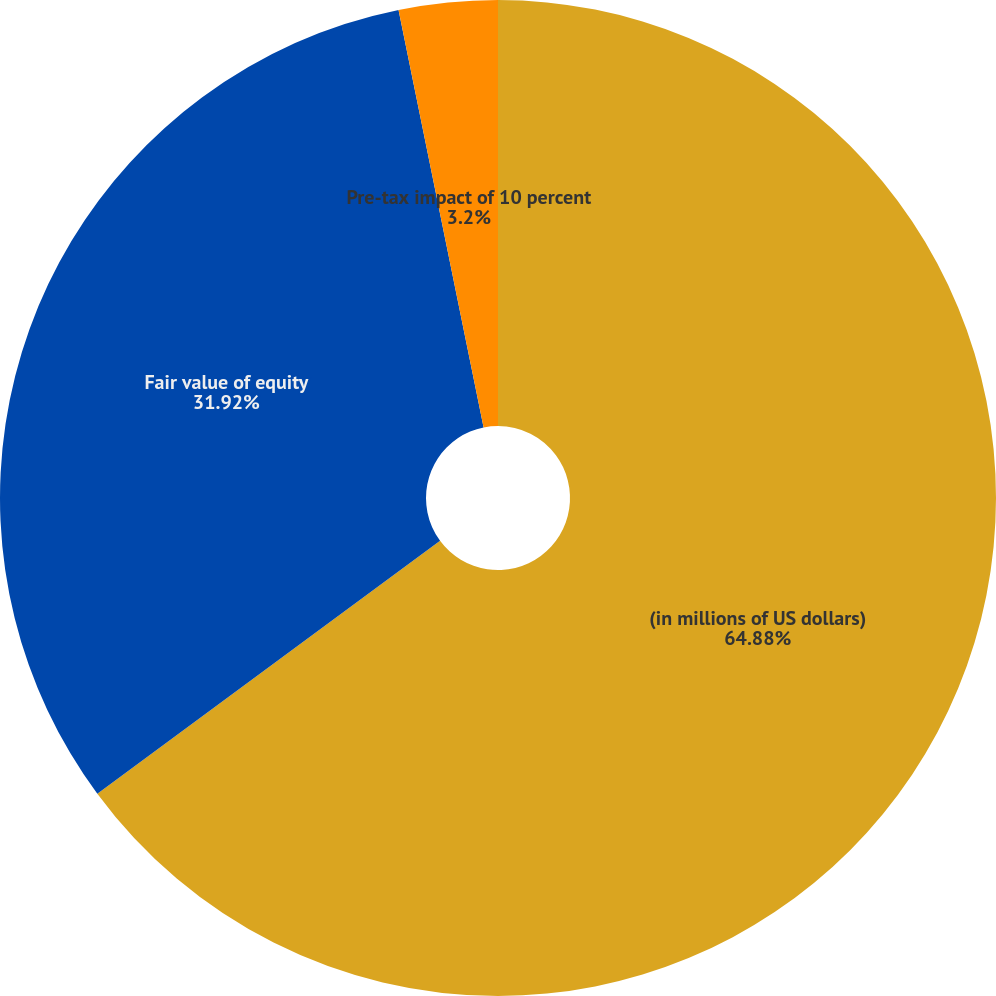Convert chart. <chart><loc_0><loc_0><loc_500><loc_500><pie_chart><fcel>(in millions of US dollars)<fcel>Fair value of equity<fcel>Pre-tax impact of 10 percent<nl><fcel>64.88%<fcel>31.92%<fcel>3.2%<nl></chart> 